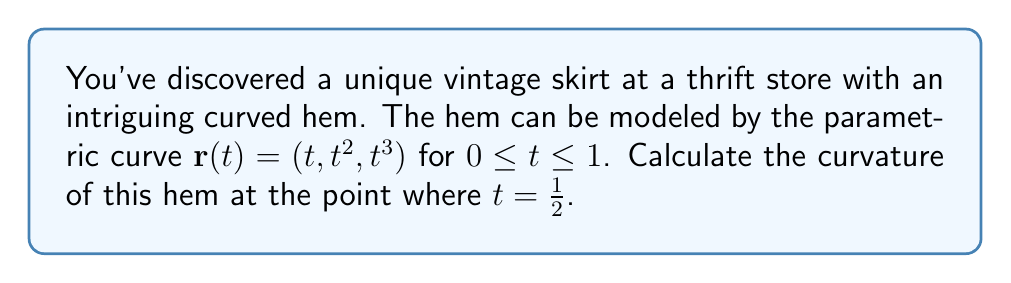Help me with this question. To calculate the curvature of the parametric curve, we'll follow these steps:

1) The curvature $\kappa$ is given by the formula:

   $$\kappa = \frac{|\mathbf{r}'(t) \times \mathbf{r}''(t)|}{|\mathbf{r}'(t)|^3}$$

2) First, let's calculate $\mathbf{r}'(t)$ and $\mathbf{r}''(t)$:
   
   $\mathbf{r}'(t) = (1, 2t, 3t^2)$
   $\mathbf{r}''(t) = (0, 2, 6t)$

3) Now, we need to calculate the cross product $\mathbf{r}'(t) \times \mathbf{r}''(t)$:

   $$\mathbf{r}'(t) \times \mathbf{r}''(t) = \begin{vmatrix} 
   \mathbf{i} & \mathbf{j} & \mathbf{k} \\
   1 & 2t & 3t^2 \\
   0 & 2 & 6t
   \end{vmatrix} = (6t^2 - 6t^2)\mathbf{i} - (6t - 0)\mathbf{j} + (2 - 4t)\mathbf{k} = -6t\mathbf{j} + (2 - 4t)\mathbf{k}$$

4) The magnitude of this cross product is:

   $$|\mathbf{r}'(t) \times \mathbf{r}''(t)| = \sqrt{36t^2 + (2-4t)^2} = \sqrt{36t^2 + 4 - 16t + 16t^2} = \sqrt{52t^2 - 16t + 4}$$

5) Next, we calculate $|\mathbf{r}'(t)|^3$:

   $$|\mathbf{r}'(t)|^3 = (1^2 + (2t)^2 + (3t^2)^2)^{3/2} = (1 + 4t^2 + 9t^4)^{3/2}$$

6) Now, we can write the full expression for curvature:

   $$\kappa(t) = \frac{\sqrt{52t^2 - 16t + 4}}{(1 + 4t^2 + 9t^4)^{3/2}}$$

7) To find the curvature at $t = \frac{1}{2}$, we substitute this value:

   $$\kappa(\frac{1}{2}) = \frac{\sqrt{52(\frac{1}{2})^2 - 16(\frac{1}{2}) + 4}}{(1 + 4(\frac{1}{2})^2 + 9(\frac{1}{2})^4)^{3/2}} = \frac{\sqrt{13 - 8 + 4}}{(1 + 1 + \frac{9}{16})^{3/2}} = \frac{3}{(\frac{41}{16})^{3/2}}$$

8) Simplifying:

   $$\kappa(\frac{1}{2}) = \frac{3 \cdot 16^{3/2}}{41^{3/2}} = \frac{3 \cdot 64}{41^{3/2}} = \frac{192}{41^{3/2}}$$
Answer: $\frac{192}{41^{3/2}}$ 